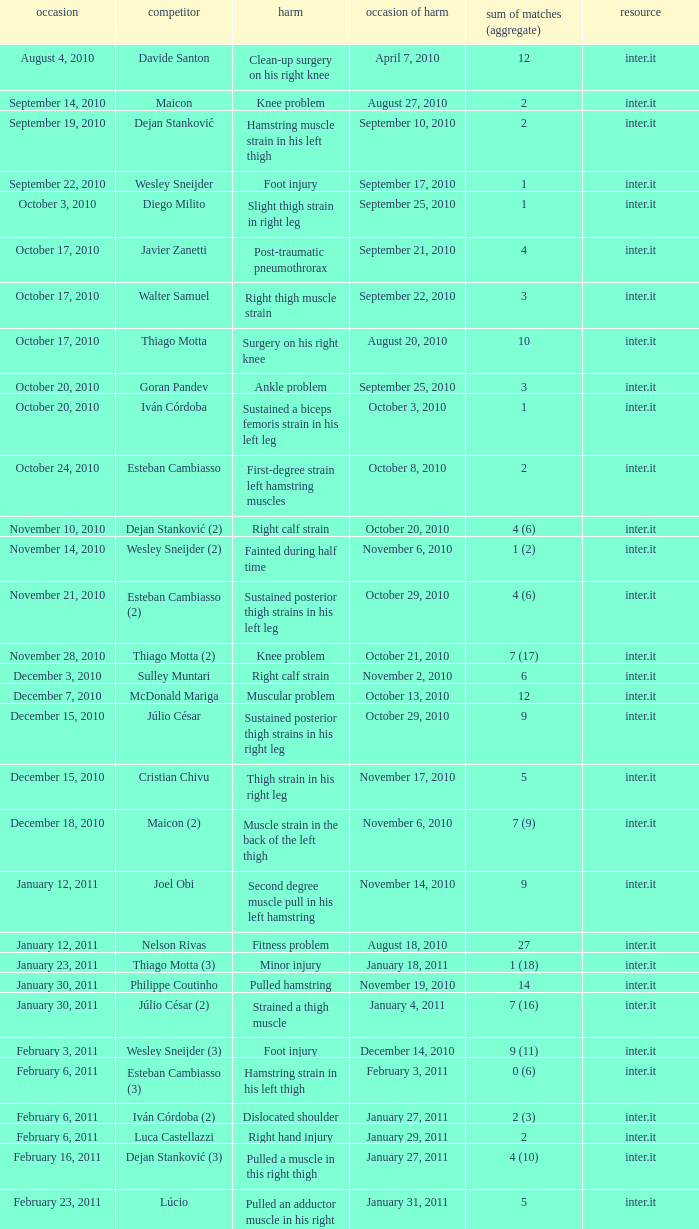How many times was the date october 3, 2010? 1.0. 